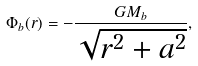Convert formula to latex. <formula><loc_0><loc_0><loc_500><loc_500>\Phi _ { b } ( r ) = - \frac { G M _ { b } } { \sqrt { r ^ { 2 } + a ^ { 2 } } } ,</formula> 